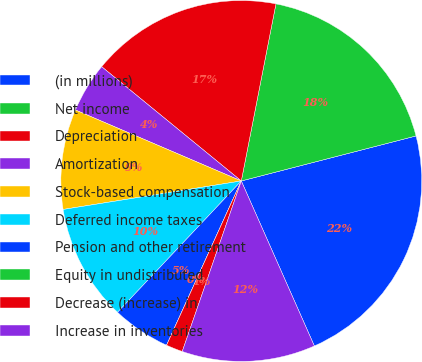Convert chart. <chart><loc_0><loc_0><loc_500><loc_500><pie_chart><fcel>(in millions)<fcel>Net income<fcel>Depreciation<fcel>Amortization<fcel>Stock-based compensation<fcel>Deferred income taxes<fcel>Pension and other retirement<fcel>Equity in undistributed<fcel>Decrease (increase) in<fcel>Increase in inventories<nl><fcel>22.38%<fcel>17.91%<fcel>17.16%<fcel>4.48%<fcel>8.96%<fcel>10.45%<fcel>5.23%<fcel>0.0%<fcel>1.49%<fcel>11.94%<nl></chart> 